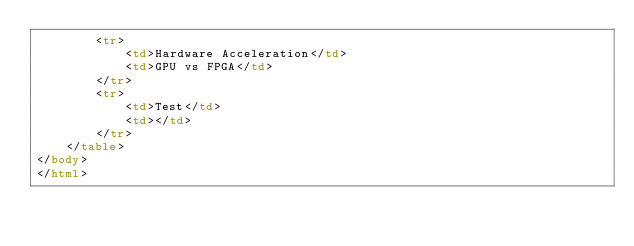<code> <loc_0><loc_0><loc_500><loc_500><_HTML_>        <tr>
            <td>Hardware Acceleration</td>
            <td>GPU vs FPGA</td>
        </tr>
        <tr>
            <td>Test</td>
            <td></td>
        </tr>
    </table>
</body>
</html></code> 